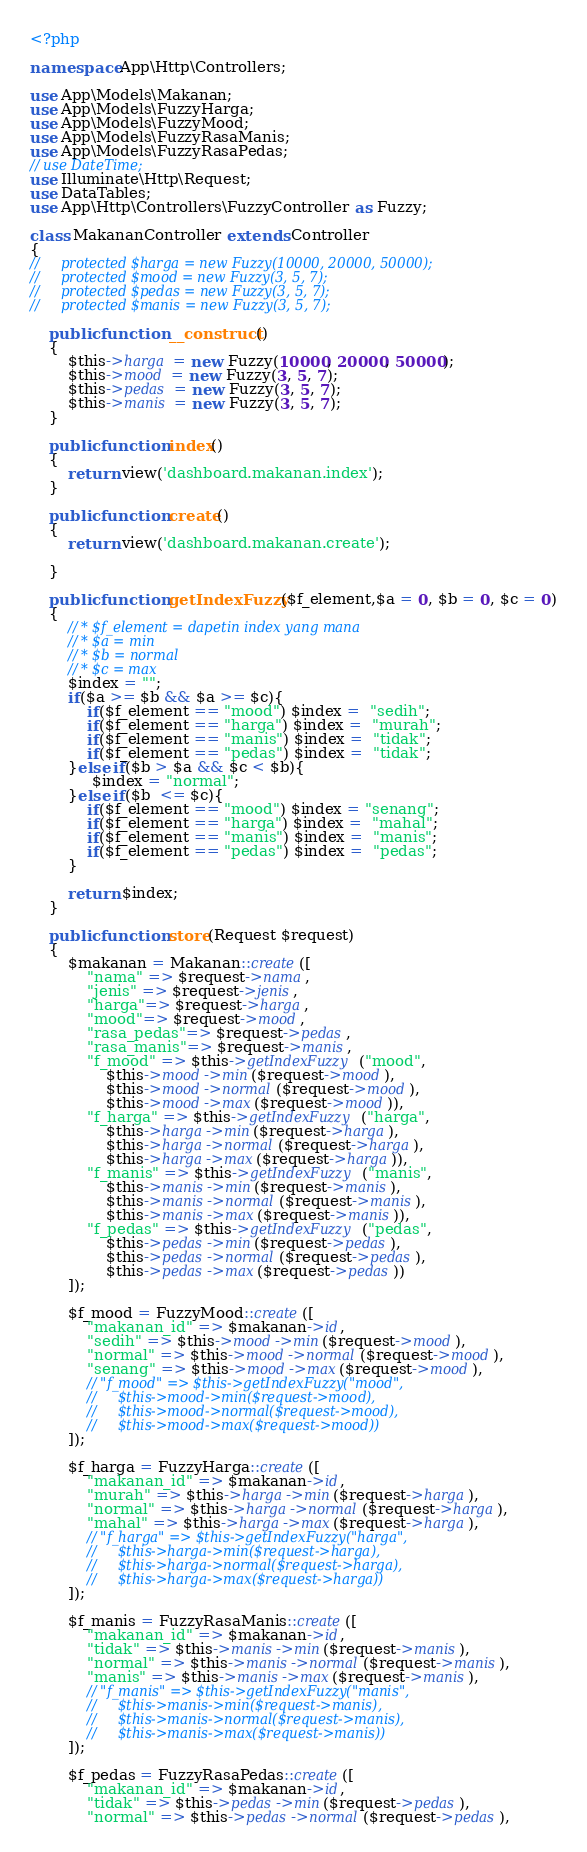Convert code to text. <code><loc_0><loc_0><loc_500><loc_500><_PHP_><?php

namespace App\Http\Controllers;

use App\Models\Makanan;
use App\Models\FuzzyHarga;
use App\Models\FuzzyMood;
use App\Models\FuzzyRasaManis;
use App\Models\FuzzyRasaPedas;
// use DateTime;
use Illuminate\Http\Request;
use DataTables;
use App\Http\Controllers\FuzzyController as Fuzzy;

class MakananController extends Controller
{
//     protected $harga = new Fuzzy(10000, 20000, 50000);
//     protected $mood = new Fuzzy(3, 5, 7);
//     protected $pedas = new Fuzzy(3, 5, 7);
//     protected $manis = new Fuzzy(3, 5, 7);

    public function __construct()
    {
        $this->harga = new Fuzzy(10000, 20000, 50000);
        $this->mood = new Fuzzy(3, 5, 7);
        $this->pedas = new Fuzzy(3, 5, 7);
        $this->manis = new Fuzzy(3, 5, 7);
    }

    public function index()
    {
        return view('dashboard.makanan.index');
    }

    public function create()
    {
        return view('dashboard.makanan.create');
        
    }

    public function getIndexFuzzy($f_element,$a = 0, $b = 0, $c = 0)
    {
        // * $f_element = dapetin index yang mana
        // * $a = min
        // * $b = normal
        // * $c = max
        $index = "";
        if($a >= $b && $a >= $c){
            if($f_element == "mood") $index =  "sedih";
            if($f_element == "harga") $index =  "murah";
            if($f_element == "manis") $index =  "tidak";
            if($f_element == "pedas") $index =  "tidak";
        }else if($b > $a && $c < $b){
             $index = "normal";
        }else if($b  <= $c){
            if($f_element == "mood") $index = "senang";
            if($f_element == "harga") $index =  "mahal";
            if($f_element == "manis") $index =  "manis";
            if($f_element == "pedas") $index =  "pedas";
        }

        return $index;
    }

    public function store(Request $request)
    {
        $makanan = Makanan::create([
            "nama" => $request->nama,
            "jenis" => $request->jenis,
            "harga"=> $request->harga,
            "mood"=> $request->mood,
            "rasa_pedas"=> $request->pedas,
            "rasa_manis"=> $request->manis,
            "f_mood" => $this->getIndexFuzzy("mood", 
                $this->mood->min($request->mood),
                $this->mood->normal($request->mood),
                $this->mood->max($request->mood)),
            "f_harga" => $this->getIndexFuzzy("harga", 
                $this->harga->min($request->harga),
                $this->harga->normal($request->harga),
                $this->harga->max($request->harga)),
            "f_manis" => $this->getIndexFuzzy("manis", 
                $this->manis->min($request->manis),
                $this->manis->normal($request->manis),
                $this->manis->max($request->manis)),
            "f_pedas" => $this->getIndexFuzzy("pedas", 
                $this->pedas->min($request->pedas),
                $this->pedas->normal($request->pedas),
                $this->pedas->max($request->pedas))
        ]);

        $f_mood = FuzzyMood::create([
            "makanan_id" => $makanan->id,
            "sedih" => $this->mood->min($request->mood),
            "normal" => $this->mood->normal($request->mood),
            "senang" => $this->mood->max($request->mood),
            // "f_mood" => $this->getIndexFuzzy("mood", 
            //     $this->mood->min($request->mood),
            //     $this->mood->normal($request->mood),
            //     $this->mood->max($request->mood))
        ]);
        
        $f_harga = FuzzyHarga::create([
            "makanan_id" => $makanan->id,
            "murah" => $this->harga->min($request->harga),
            "normal" => $this->harga->normal($request->harga),
            "mahal" => $this->harga->max($request->harga),
            // "f_harga" => $this->getIndexFuzzy("harga", 
            //     $this->harga->min($request->harga),
            //     $this->harga->normal($request->harga),
            //     $this->harga->max($request->harga))
        ]);

        $f_manis = FuzzyRasaManis::create([
            "makanan_id" => $makanan->id,
            "tidak" => $this->manis->min($request->manis),
            "normal" => $this->manis->normal($request->manis),
            "manis" => $this->manis->max($request->manis),
            // "f_manis" => $this->getIndexFuzzy("manis", 
            //     $this->manis->min($request->manis),
            //     $this->manis->normal($request->manis),
            //     $this->manis->max($request->manis))
        ]);

        $f_pedas = FuzzyRasaPedas::create([
            "makanan_id" => $makanan->id,
            "tidak" => $this->pedas->min($request->pedas),
            "normal" => $this->pedas->normal($request->pedas),</code> 